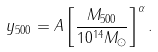Convert formula to latex. <formula><loc_0><loc_0><loc_500><loc_500>y _ { 5 0 0 } = A \left [ \frac { M _ { 5 0 0 } } { 1 0 ^ { 1 4 } M _ { \odot } } \right ] ^ { \alpha } .</formula> 